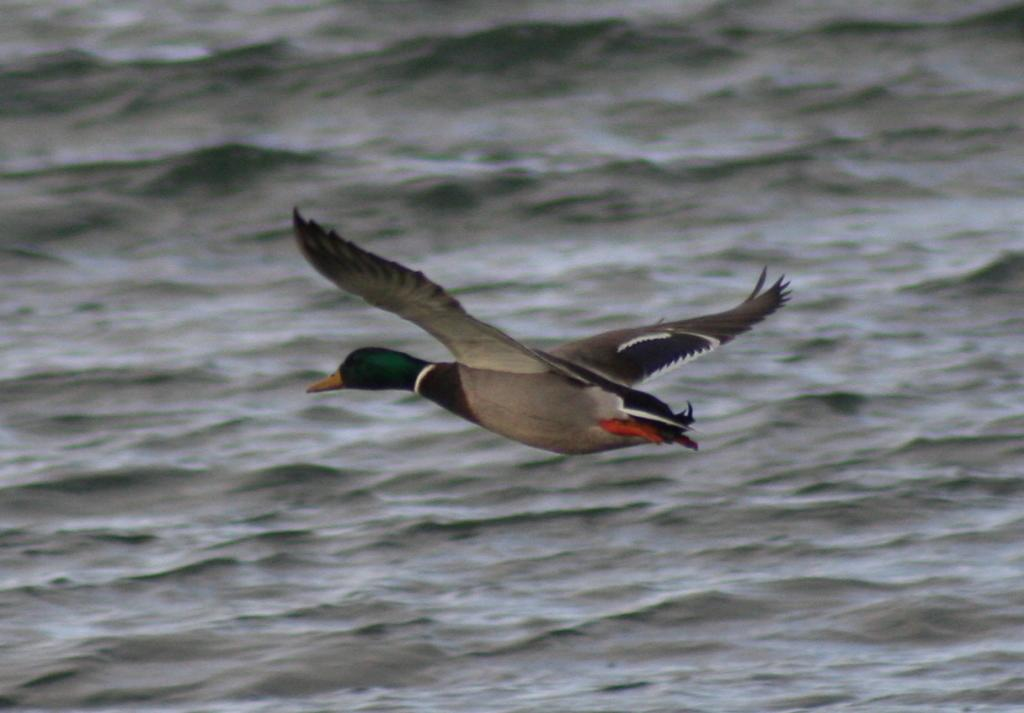What is located in the center of the image? There is a bird in the center of the image. What can be seen in the background of the image? There is water visible in the background of the image. What type of hill can be seen in the image? There is no hill present in the image. Can you tell me how the bird is caring for its young in the image? The image does not show the bird interacting with its young, so it cannot be determined from the picture. 